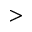<formula> <loc_0><loc_0><loc_500><loc_500>></formula> 